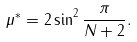Convert formula to latex. <formula><loc_0><loc_0><loc_500><loc_500>\mu ^ { * } = 2 \sin ^ { 2 } \frac { \pi } { N + 2 } .</formula> 